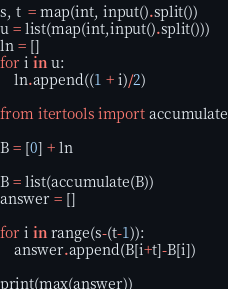<code> <loc_0><loc_0><loc_500><loc_500><_Python_>s, t  = map(int, input().split())
u = list(map(int,input().split()))
ln = []
for i in u:
    ln.append((1 + i)/2)

from itertools import accumulate

B = [0] + ln

B = list(accumulate(B)) 
answer = []

for i in range(s-(t-1)):
    answer.append(B[i+t]-B[i])

print(max(answer)) </code> 